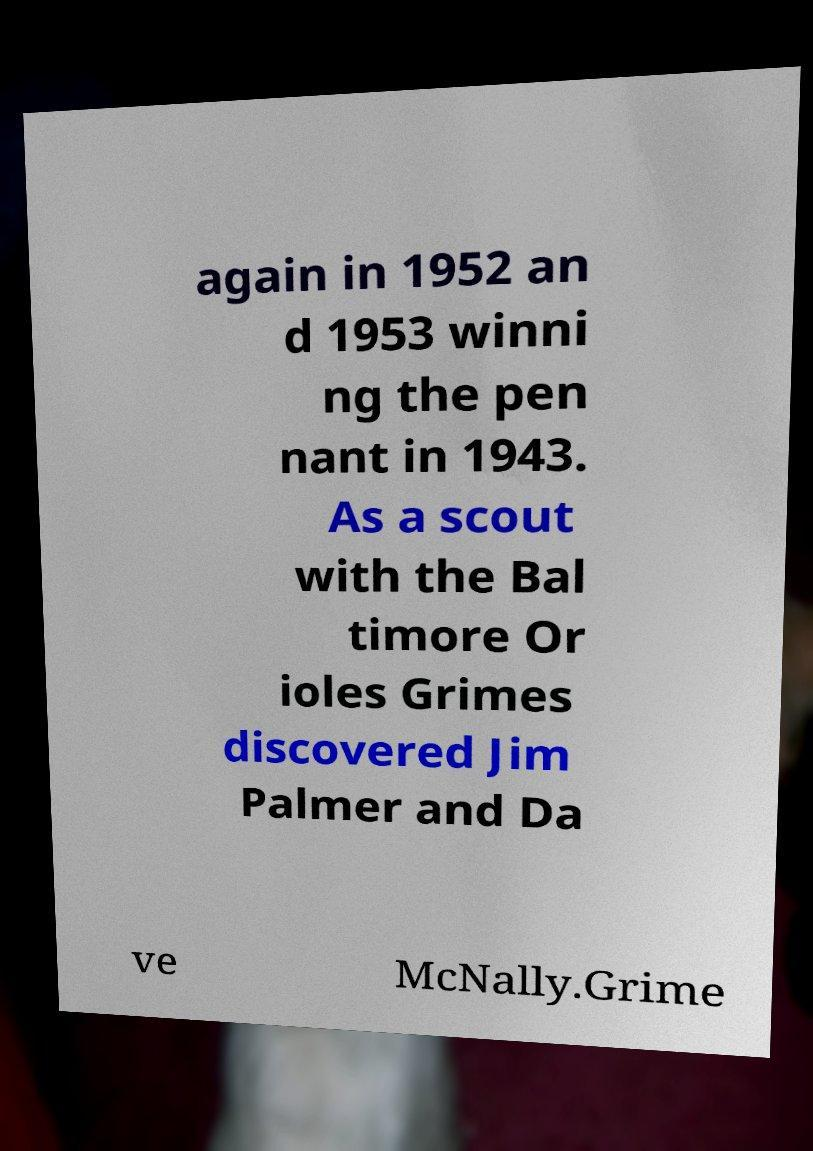I need the written content from this picture converted into text. Can you do that? again in 1952 an d 1953 winni ng the pen nant in 1943. As a scout with the Bal timore Or ioles Grimes discovered Jim Palmer and Da ve McNally.Grime 